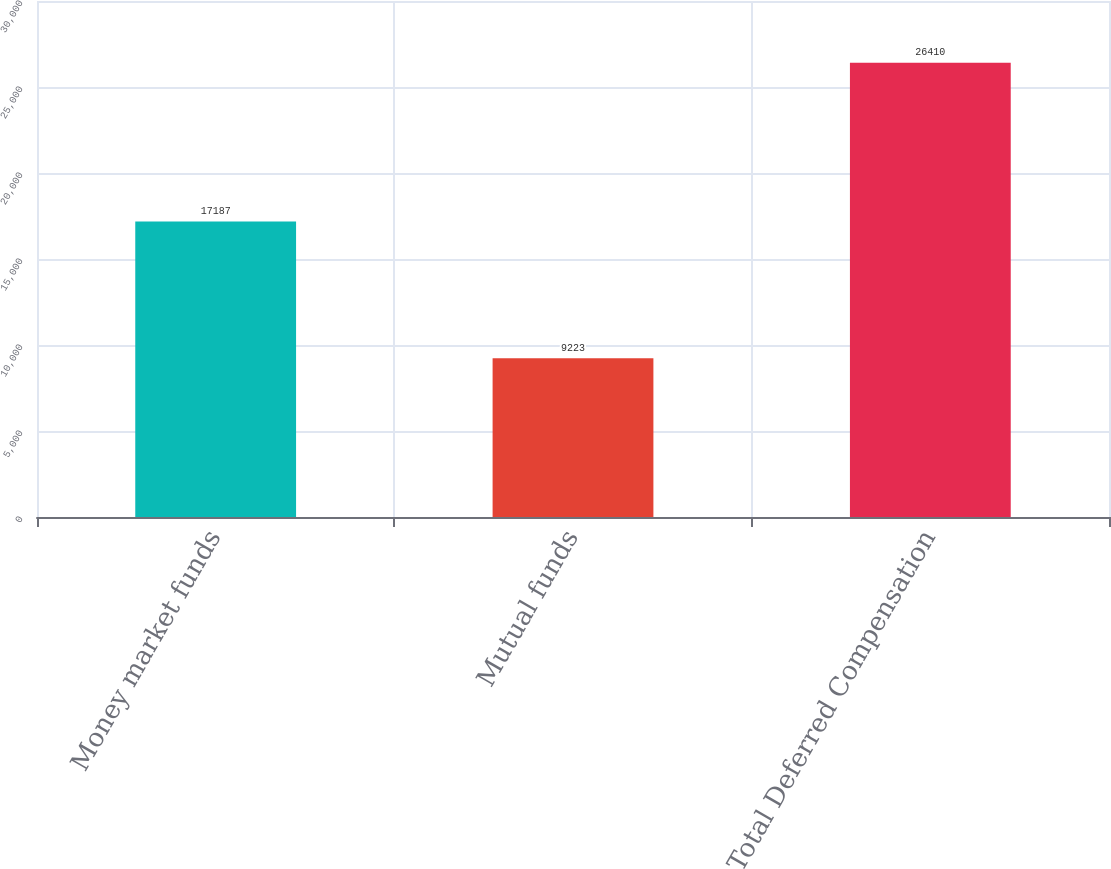<chart> <loc_0><loc_0><loc_500><loc_500><bar_chart><fcel>Money market funds<fcel>Mutual funds<fcel>Total Deferred Compensation<nl><fcel>17187<fcel>9223<fcel>26410<nl></chart> 